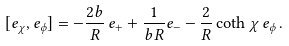Convert formula to latex. <formula><loc_0><loc_0><loc_500><loc_500>[ e _ { \chi } , e _ { \phi } ] = - \frac { 2 b } { R } \, e _ { + } + \frac { 1 } { b R } e _ { - } - \frac { 2 } { R } \coth \chi \, e _ { \phi } \, .</formula> 